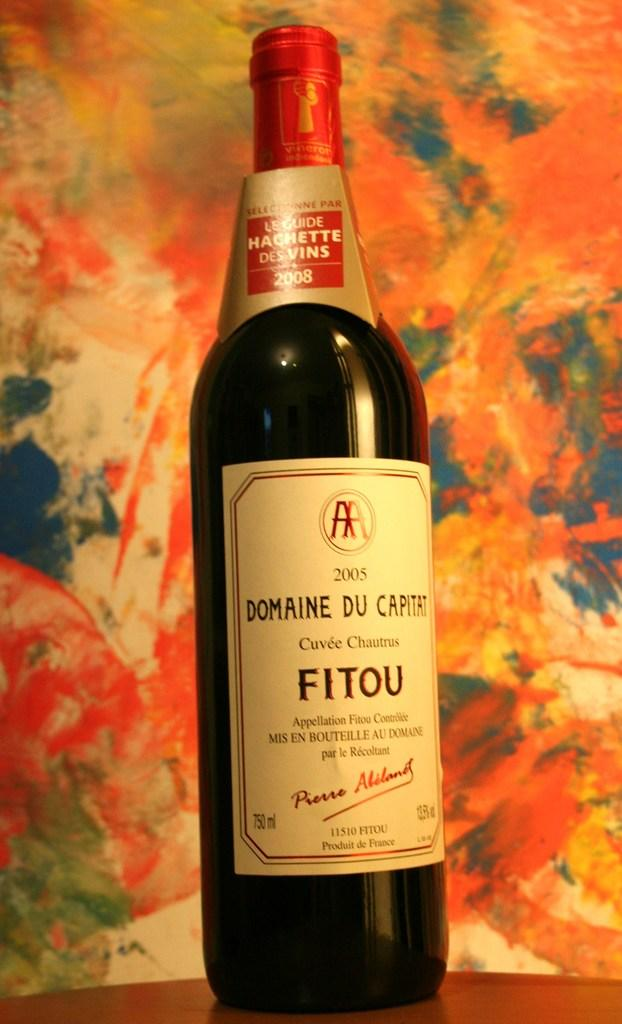<image>
Write a terse but informative summary of the picture. A bottle of Domaine Du Capitat is in front of a very colorful wall. 